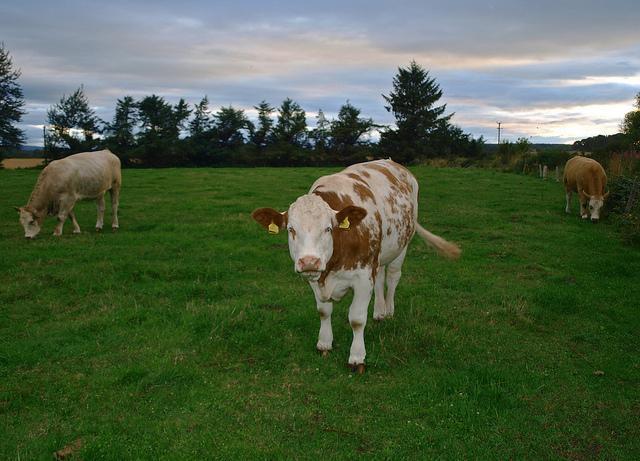How many cows are there?
Give a very brief answer. 2. 